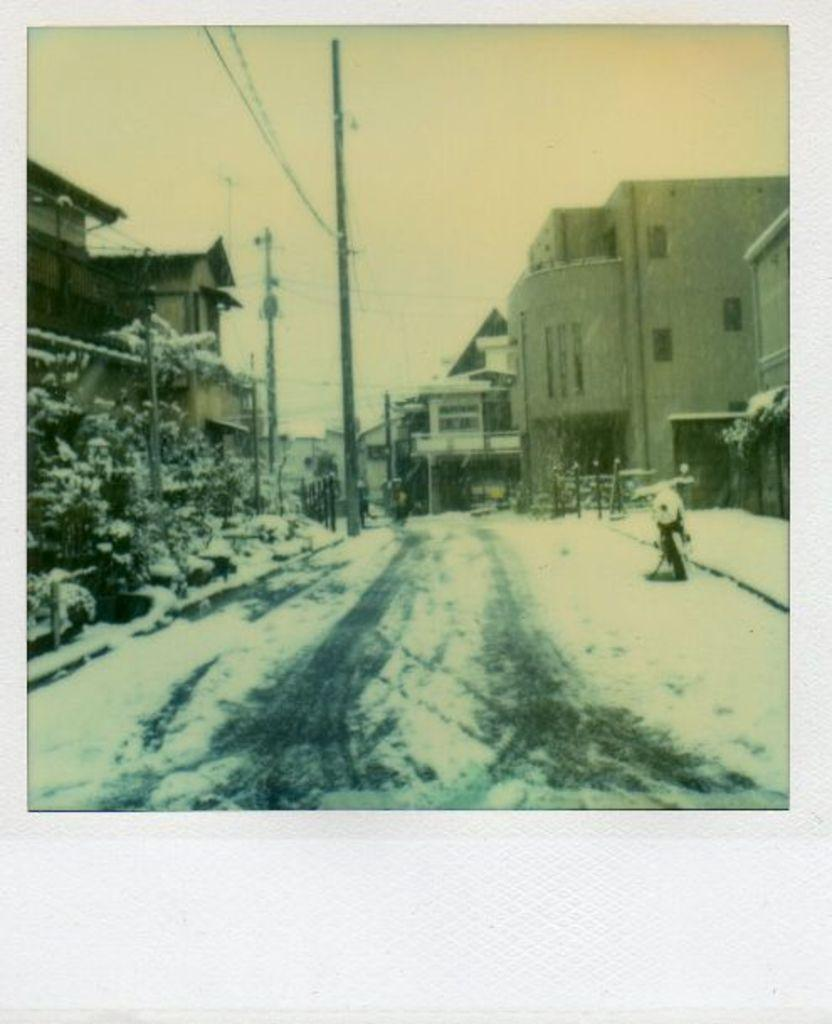What is the main feature in the center of the image? There is a road in the center of the image. What is the weather condition in the image? There is snow in the image. What type of vehicle can be seen in the image? There is a vehicle in the image. What structures are present in the image? There are buildings in the image. What else can be seen in the image besides the road, snow, vehicle, and buildings? There are electric poles and wires in the image. What is visible at the top of the image? The sky is visible at the top of the image. What type of account is being discussed in the image? There is no discussion of an account in the image; it features a road, snow, a vehicle, buildings, electric poles, wires, and the sky. Can you tell me how many vessels are visible in the image? There are no vessels present in the image. 